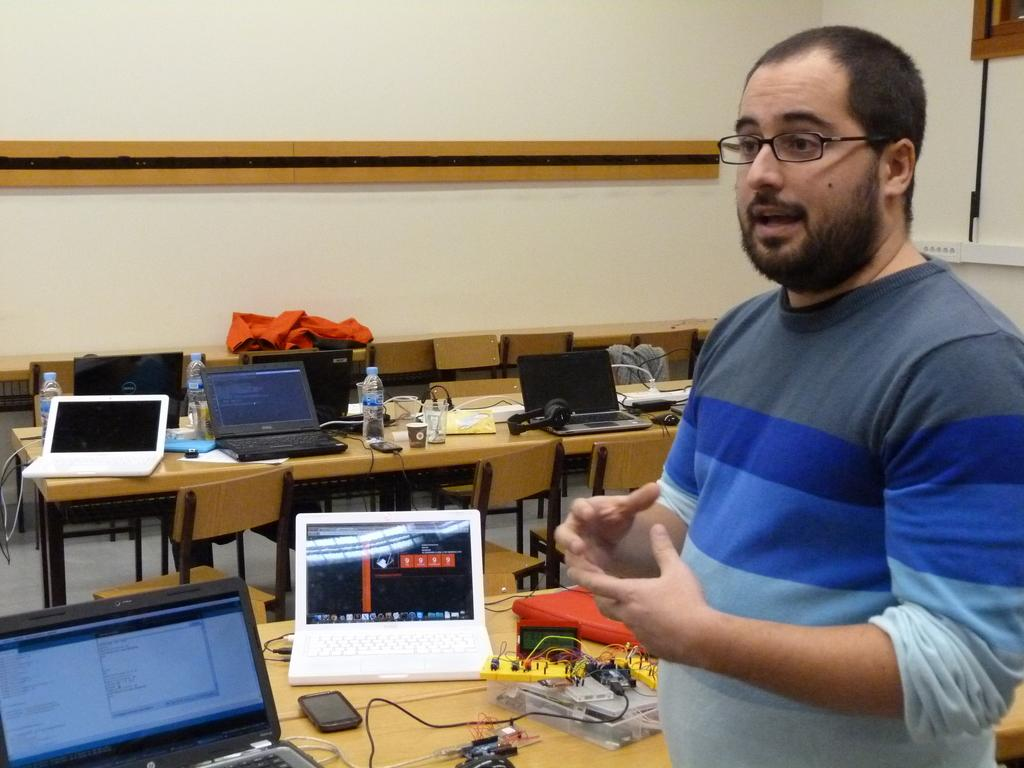What is the main subject in the image? There is a person standing in the image. What is the person standing near in the image? There is a table in the image. What electronic devices can be seen on the table? There are laptops, a mobile phone, and other electronic gadgets on the table. What can be used for hydration on the table? There is a water bottle on the table. Is there a chair next to the person in the image? The provided facts do not mention a chair, so we cannot determine if there is one in the image. Can you see a hill in the background of the image? There is no mention of a hill or any background in the provided facts, so we cannot determine if there is one in the image. 